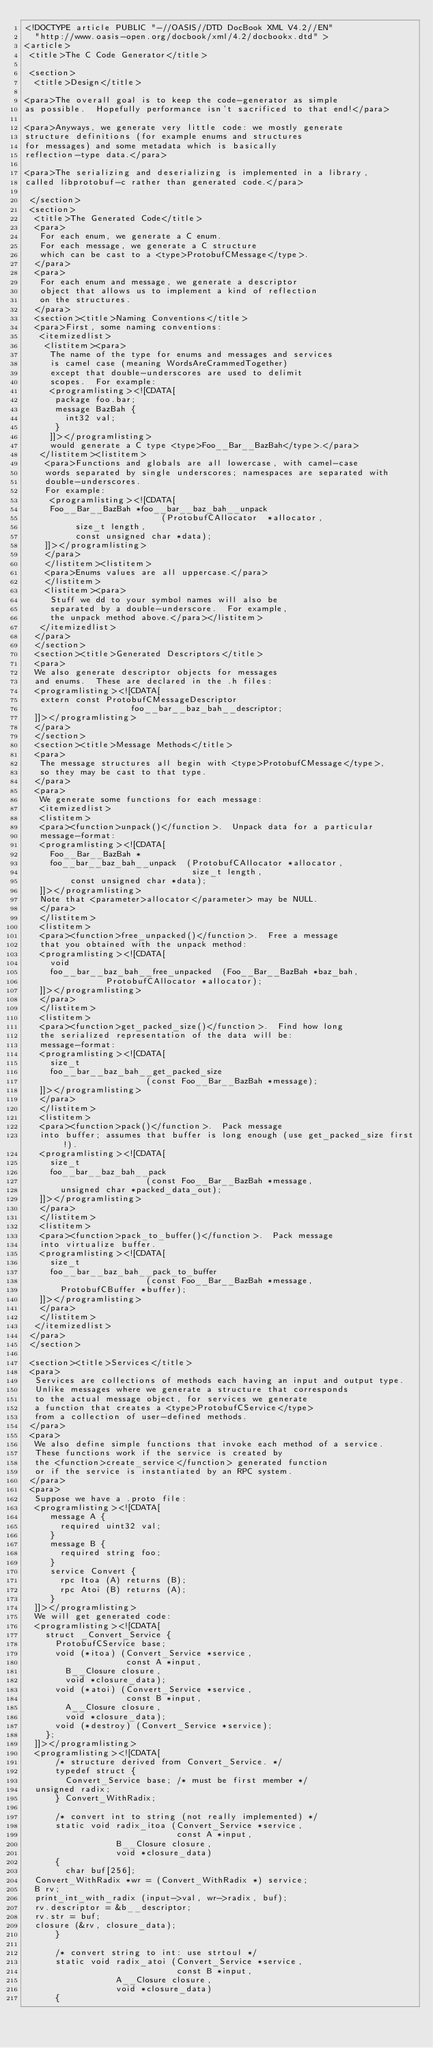Convert code to text. <code><loc_0><loc_0><loc_500><loc_500><_XML_><!DOCTYPE article PUBLIC "-//OASIS//DTD DocBook XML V4.2//EN"
  "http://www.oasis-open.org/docbook/xml/4.2/docbookx.dtd" >
<article>
 <title>The C Code Generator</title>

 <section>
  <title>Design</title>

<para>The overall goal is to keep the code-generator as simple
as possible.  Hopefully performance isn't sacrificed to that end!</para>

<para>Anyways, we generate very little code: we mostly generate
structure definitions (for example enums and structures
for messages) and some metadata which is basically
reflection-type data.</para>

<para>The serializing and deserializing is implemented in a library,
called libprotobuf-c rather than generated code.</para>

 </section>
 <section>
  <title>The Generated Code</title>
  <para>
   For each enum, we generate a C enum.
   For each message, we generate a C structure
   which can be cast to a <type>ProtobufCMessage</type>.
  </para>
  <para>
   For each enum and message, we generate a descriptor
   object that allows us to implement a kind of reflection
   on the structures.
  </para>
  <section><title>Naming Conventions</title>
  <para>First, some naming conventions:
   <itemizedlist>
    <listitem><para>
     The name of the type for enums and messages and services
     is camel case (meaning WordsAreCrammedTogether)
     except that double-underscores are used to delimit
     scopes.  For example:
     <programlisting><![CDATA[
      package foo.bar;
      message BazBah {
        int32 val;
      }
     ]]></programlisting>
     would generate a C type <type>Foo__Bar__BazBah</type>.</para>
   </listitem><listitem>
    <para>Functions and globals are all lowercase, with camel-case
    words separated by single underscores; namespaces are separated with
    double-underscores.
    For example:
     <programlisting><![CDATA[
     Foo__Bar__BazBah *foo__bar__baz_bah__unpack
                           (ProtobufCAllocator  *allocator,
			    size_t length,
			    const unsigned char *data);
    ]]></programlisting>
    </para>
    </listitem><listitem>
    <para>Enums values are all uppercase.</para>
    </listitem>
    <listitem><para>
     Stuff we dd to your symbol names will also be
     separated by a double-underscore.  For example,
     the unpack method above.</para></listitem>
   </itemizedlist>
  </para>
  </section>
  <section><title>Generated Descriptors</title>
  <para>
  We also generate descriptor objects for messages
  and enums.  These are declared in the .h files:
  <programlisting><![CDATA[
   extern const ProtobufCMessageDescriptor
                     foo__bar__baz_bah__descriptor;
  ]]></programlisting>
  </para>
  </section>
  <section><title>Message Methods</title>
  <para>
   The message structures all begin with <type>ProtobufCMessage</type>,
   so they may be cast to that type.
  </para>
  <para>
   We generate some functions for each message:
   <itemizedlist>
   <listitem>
   <para><function>unpack()</function>.  Unpack data for a particular
   message-format:
   <programlisting><![CDATA[
     Foo__Bar__BazBah *
     foo__bar__baz_bah__unpack  (ProtobufCAllocator *allocator,
                                 size_t length,
				 const unsigned char *data);
   ]]></programlisting>
   Note that <parameter>allocator</parameter> may be NULL.
   </para>
   </listitem>
   <listitem>
   <para><function>free_unpacked()</function>.  Free a message
   that you obtained with the unpack method:
   <programlisting><![CDATA[
     void
     foo__bar__baz_bah__free_unpacked  (Foo__Bar__BazBah *baz_bah,
				        ProtobufCAllocator *allocator);
   ]]></programlisting>
   </para>
   </listitem>
   <listitem>
   <para><function>get_packed_size()</function>.  Find how long 
   the serialized representation of the data will be:
   message-format:
   <programlisting><![CDATA[
     size_t
     foo__bar__baz_bah__get_packed_size 
                        (const Foo__Bar__BazBah *message);
   ]]></programlisting>
   </para>
   </listitem>
   <listitem>
   <para><function>pack()</function>.  Pack message
   into buffer; assumes that buffer is long enough (use get_packed_size first!).
   <programlisting><![CDATA[
     size_t
     foo__bar__baz_bah__pack
                        (const Foo__Bar__BazBah *message,
			 unsigned char *packed_data_out);
   ]]></programlisting>
   </para>
   </listitem>
   <listitem>
   <para><function>pack_to_buffer()</function>.  Pack message
   into virtualize buffer.
   <programlisting><![CDATA[
     size_t
     foo__bar__baz_bah__pack_to_buffer
                        (const Foo__Bar__BazBah *message,
			 ProtobufCBuffer *buffer);
   ]]></programlisting>
   </para>
   </listitem>
  </itemizedlist>
 </para>
 </section>

 <section><title>Services</title>
 <para>
  Services are collections of methods each having an input and output type.
  Unlike messages where we generate a structure that corresponds
  to the actual message object, for services we generate
  a function that creates a <type>ProtobufCService</type>
  from a collection of user-defined methods.
 </para>
 <para>
  We also define simple functions that invoke each method of a service.
  These functions work if the service is created by
  the <function>create_service</function> generated function
  or if the service is instantiated by an RPC system.
 </para>
 <para>
  Suppose we have a .proto file:
  <programlisting><![CDATA[
     message A {
       required uint32 val;
     }
     message B {
       required string foo;
     }
     service Convert {
       rpc Itoa (A) returns (B);
       rpc Atoi (B) returns (A);
     }
  ]]></programlisting>
  We will get generated code:
  <programlisting><![CDATA[
    struct _Convert_Service {
      ProtobufCService base;
      void (*itoa) (Convert_Service *service,
                    const A *input,
		    B__Closure closure,
		    void *closure_data);
      void (*atoi) (Convert_Service *service,
                    const B *input,
		    A__Closure closure,
		    void *closure_data);
      void (*destroy) (Convert_Service *service);
    };
  ]]></programlisting>
  <programlisting><![CDATA[
      /* structure derived from Convert_Service. */
      typedef struct {
        Convert_Service base;	/* must be first member */
	unsigned radix;
      } Convert_WithRadix;

      /* convert int to string (not really implemented) */
      static void radix_itoa (Convert_Service *service,
                              const A *input,
		              B__Closure closure,
		              void *closure_data)
      {
        char buf[256];
	Convert_WithRadix *wr = (Convert_WithRadix *) service;
	B rv;
	print_int_with_radix (input->val, wr->radix, buf);
	rv.descriptor = &b__descriptor;
	rv.str = buf;
	closure (&rv, closure_data);
      }

      /* convert string to int: use strtoul */
      static void radix_atoi (Convert_Service *service,
                              const B *input,
		              A__Closure closure,
		              void *closure_data)
      {</code> 